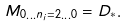<formula> <loc_0><loc_0><loc_500><loc_500>M _ { 0 \dots n _ { i } = 2 \dots 0 } = D _ { * } .</formula> 